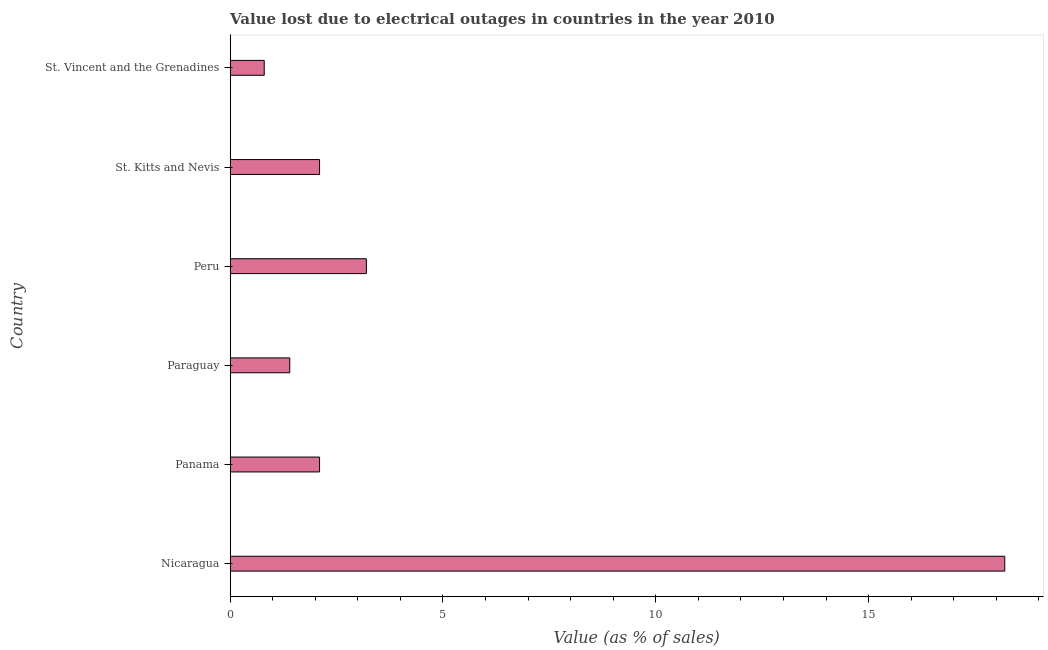Does the graph contain any zero values?
Provide a short and direct response. No. What is the title of the graph?
Offer a terse response. Value lost due to electrical outages in countries in the year 2010. What is the label or title of the X-axis?
Keep it short and to the point. Value (as % of sales). Across all countries, what is the maximum value lost due to electrical outages?
Offer a very short reply. 18.2. In which country was the value lost due to electrical outages maximum?
Provide a short and direct response. Nicaragua. In which country was the value lost due to electrical outages minimum?
Provide a succinct answer. St. Vincent and the Grenadines. What is the sum of the value lost due to electrical outages?
Your answer should be very brief. 27.8. What is the average value lost due to electrical outages per country?
Provide a succinct answer. 4.63. What is the ratio of the value lost due to electrical outages in Nicaragua to that in St. Vincent and the Grenadines?
Offer a terse response. 22.75. Is the value lost due to electrical outages in Panama less than that in St. Kitts and Nevis?
Provide a succinct answer. No. Is the difference between the value lost due to electrical outages in Panama and St. Kitts and Nevis greater than the difference between any two countries?
Keep it short and to the point. No. What is the difference between the highest and the lowest value lost due to electrical outages?
Provide a succinct answer. 17.4. In how many countries, is the value lost due to electrical outages greater than the average value lost due to electrical outages taken over all countries?
Your answer should be compact. 1. Are all the bars in the graph horizontal?
Provide a short and direct response. Yes. How many countries are there in the graph?
Give a very brief answer. 6. What is the Value (as % of sales) in Panama?
Your answer should be compact. 2.1. What is the Value (as % of sales) of Paraguay?
Offer a very short reply. 1.4. What is the Value (as % of sales) in Peru?
Make the answer very short. 3.2. What is the Value (as % of sales) of St. Kitts and Nevis?
Your answer should be very brief. 2.1. What is the Value (as % of sales) in St. Vincent and the Grenadines?
Provide a short and direct response. 0.8. What is the difference between the Value (as % of sales) in Nicaragua and Panama?
Give a very brief answer. 16.1. What is the difference between the Value (as % of sales) in Nicaragua and Peru?
Your answer should be compact. 15. What is the difference between the Value (as % of sales) in Nicaragua and St. Kitts and Nevis?
Your response must be concise. 16.1. What is the difference between the Value (as % of sales) in Panama and Peru?
Ensure brevity in your answer.  -1.1. What is the difference between the Value (as % of sales) in Panama and St. Kitts and Nevis?
Your response must be concise. 0. What is the difference between the Value (as % of sales) in Paraguay and Peru?
Make the answer very short. -1.8. What is the difference between the Value (as % of sales) in Paraguay and St. Vincent and the Grenadines?
Make the answer very short. 0.6. What is the difference between the Value (as % of sales) in Peru and St. Kitts and Nevis?
Your response must be concise. 1.1. What is the difference between the Value (as % of sales) in Peru and St. Vincent and the Grenadines?
Make the answer very short. 2.4. What is the difference between the Value (as % of sales) in St. Kitts and Nevis and St. Vincent and the Grenadines?
Offer a very short reply. 1.3. What is the ratio of the Value (as % of sales) in Nicaragua to that in Panama?
Provide a succinct answer. 8.67. What is the ratio of the Value (as % of sales) in Nicaragua to that in Peru?
Keep it short and to the point. 5.69. What is the ratio of the Value (as % of sales) in Nicaragua to that in St. Kitts and Nevis?
Offer a terse response. 8.67. What is the ratio of the Value (as % of sales) in Nicaragua to that in St. Vincent and the Grenadines?
Provide a short and direct response. 22.75. What is the ratio of the Value (as % of sales) in Panama to that in Peru?
Keep it short and to the point. 0.66. What is the ratio of the Value (as % of sales) in Panama to that in St. Vincent and the Grenadines?
Offer a very short reply. 2.62. What is the ratio of the Value (as % of sales) in Paraguay to that in Peru?
Provide a succinct answer. 0.44. What is the ratio of the Value (as % of sales) in Paraguay to that in St. Kitts and Nevis?
Your response must be concise. 0.67. What is the ratio of the Value (as % of sales) in Paraguay to that in St. Vincent and the Grenadines?
Offer a very short reply. 1.75. What is the ratio of the Value (as % of sales) in Peru to that in St. Kitts and Nevis?
Your answer should be very brief. 1.52. What is the ratio of the Value (as % of sales) in Peru to that in St. Vincent and the Grenadines?
Your answer should be compact. 4. What is the ratio of the Value (as % of sales) in St. Kitts and Nevis to that in St. Vincent and the Grenadines?
Keep it short and to the point. 2.62. 